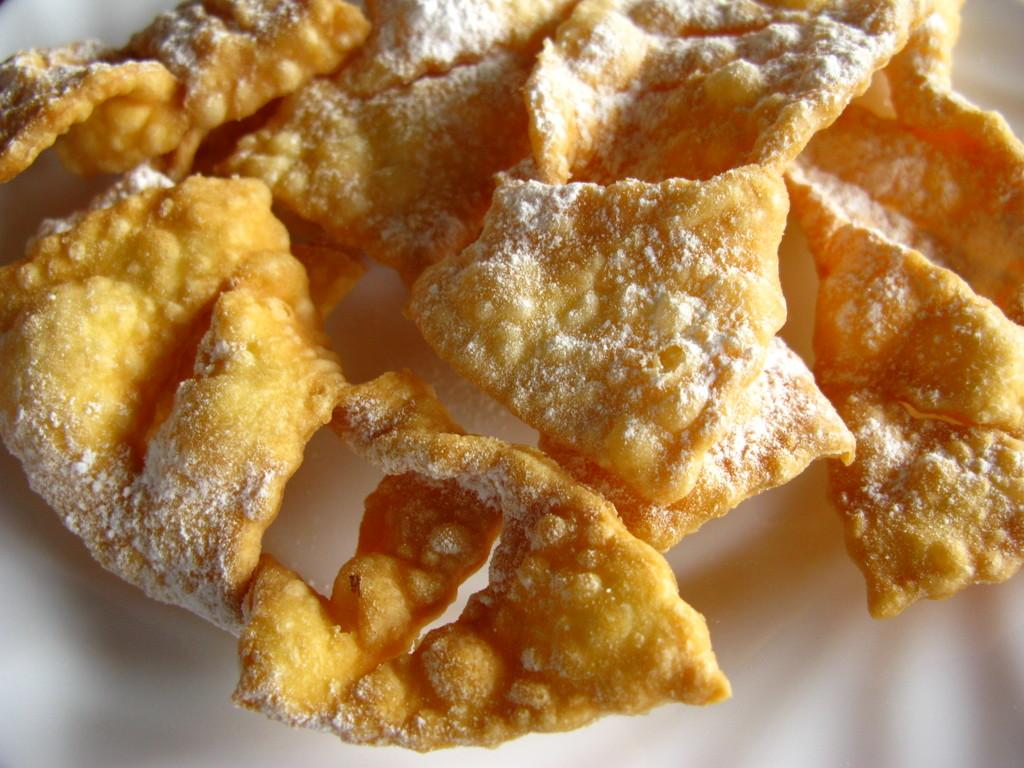What is placed on a plate in the image? There is a food item placed on a plate in the image. What direction is the sock facing in the image? There is no sock present in the image. What type of vegetable is depicted next to the food item on the plate? The fact provided does not mention any specific type of food item or vegetable, so we cannot determine if celery is present in the image. 